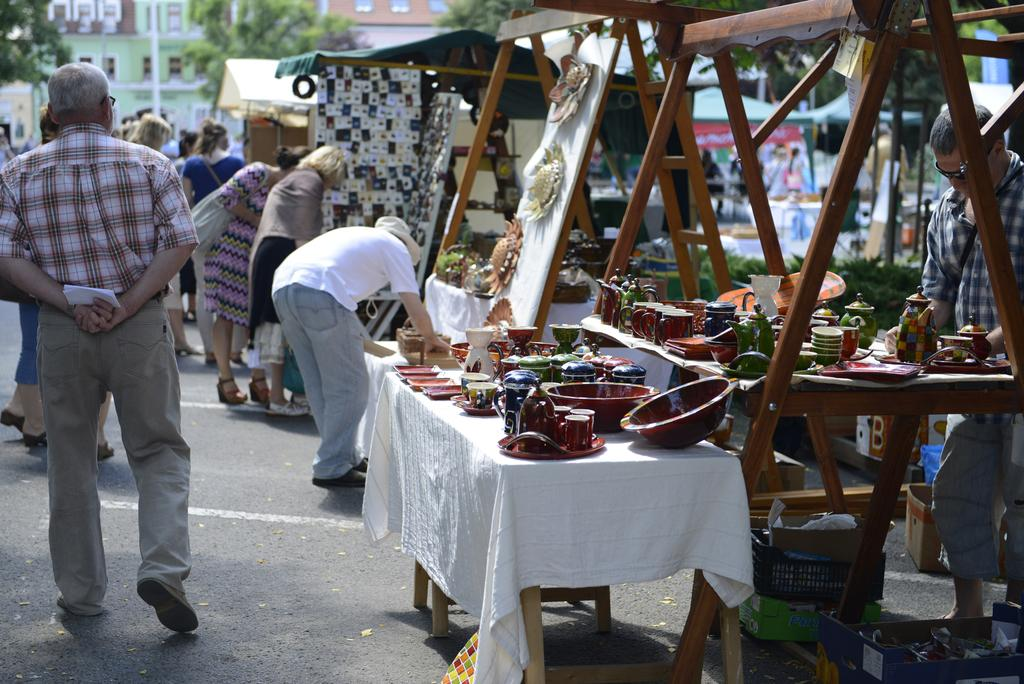What is the main feature of the image? There is a road in the image. What is happening on the road? There are people on the road. What can be found alongside the road? There are stalls in the image. What is being sold or displayed in the stalls? There are items visible in the stalls. What can be seen in the distance in the image? There are trees and buildings in the background of the image. What type of wire is being used in the process on the stage in the image? There is no wire, process, or stage present in the image. 